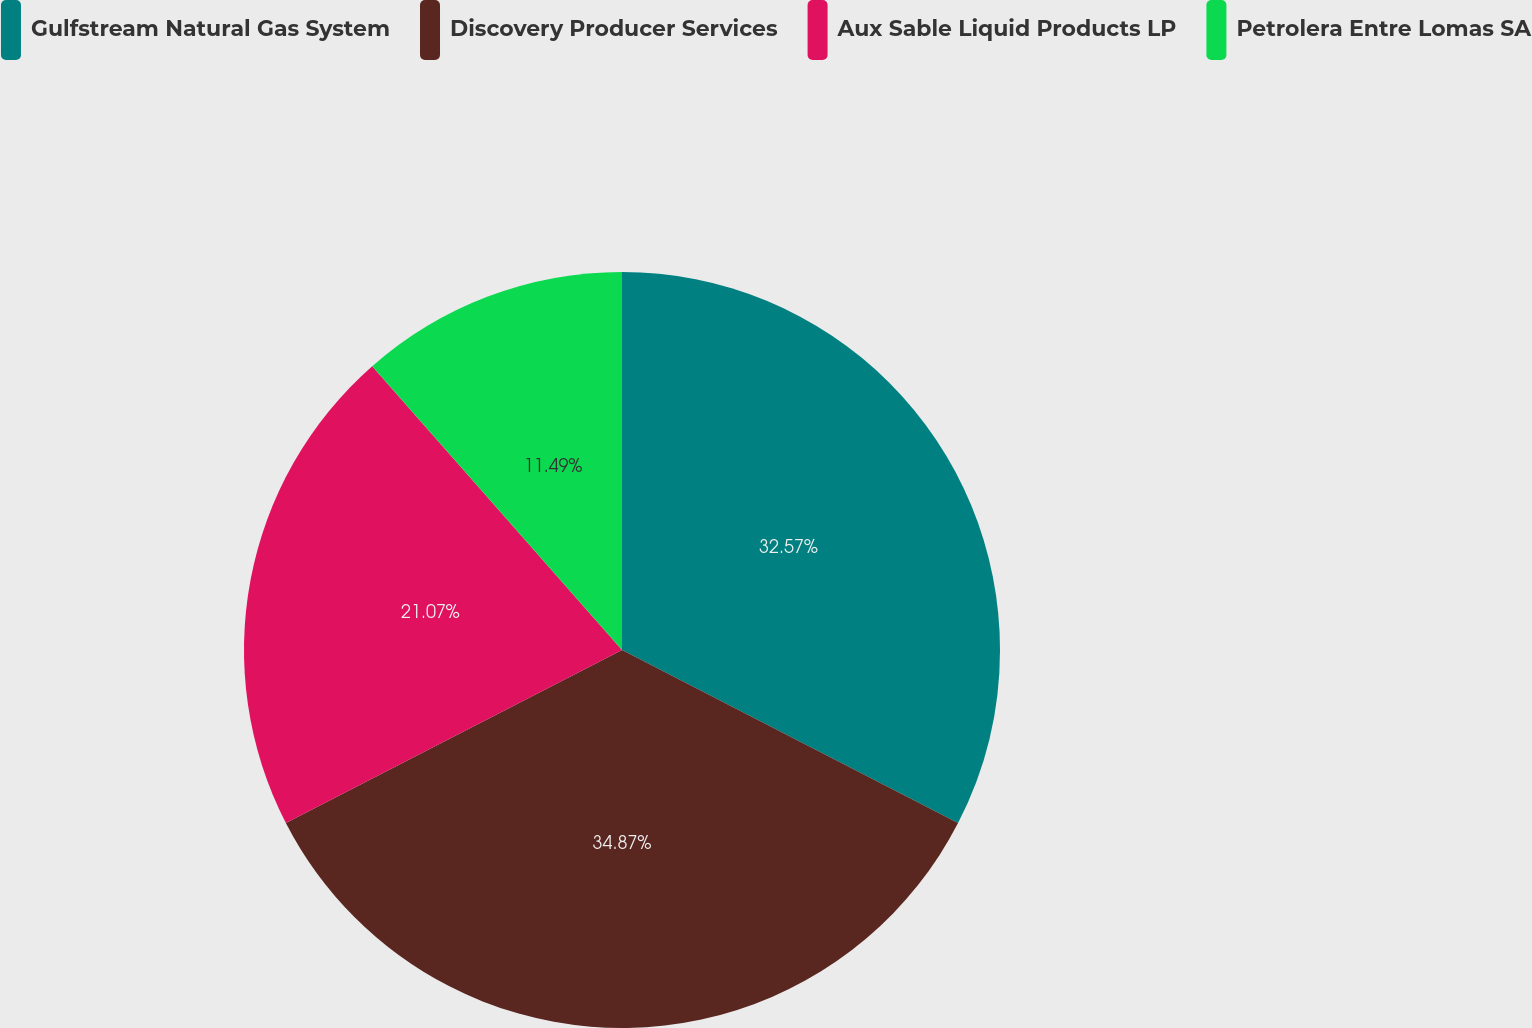Convert chart. <chart><loc_0><loc_0><loc_500><loc_500><pie_chart><fcel>Gulfstream Natural Gas System<fcel>Discovery Producer Services<fcel>Aux Sable Liquid Products LP<fcel>Petrolera Entre Lomas SA<nl><fcel>32.57%<fcel>34.87%<fcel>21.07%<fcel>11.49%<nl></chart> 